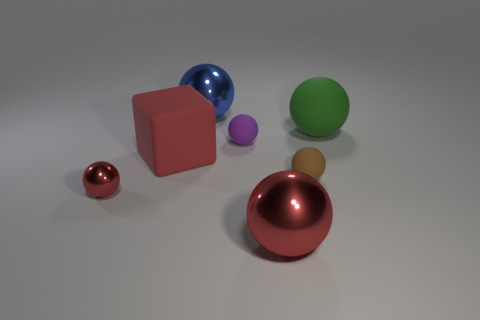How many tiny rubber things are to the left of the large object that is left of the big thing that is behind the large green object?
Provide a short and direct response. 0. What is the material of the small thing that is the same color as the block?
Provide a succinct answer. Metal. Is there any other thing that has the same shape as the big red metallic object?
Your answer should be compact. Yes. What number of objects are objects behind the green sphere or small spheres?
Your answer should be compact. 4. Does the object that is behind the large green ball have the same color as the matte block?
Offer a very short reply. No. What shape is the tiny object on the left side of the large red thing that is to the left of the tiny purple sphere?
Give a very brief answer. Sphere. Are there fewer large red balls behind the large blue metal sphere than big blue spheres left of the small red sphere?
Your response must be concise. No. There is a purple object that is the same shape as the large blue metal object; what is its size?
Offer a terse response. Small. How many things are tiny objects that are behind the big red matte thing or large metal things to the right of the purple rubber ball?
Make the answer very short. 2. Is the size of the purple object the same as the blue ball?
Ensure brevity in your answer.  No. 